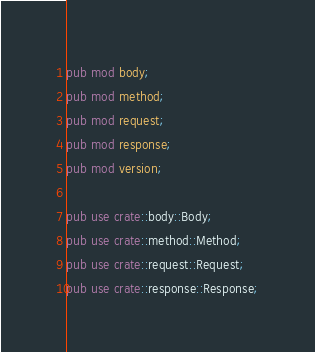Convert code to text. <code><loc_0><loc_0><loc_500><loc_500><_Rust_>pub mod body;
pub mod method;
pub mod request;
pub mod response;
pub mod version;

pub use crate::body::Body;
pub use crate::method::Method;
pub use crate::request::Request;
pub use crate::response::Response;
</code> 